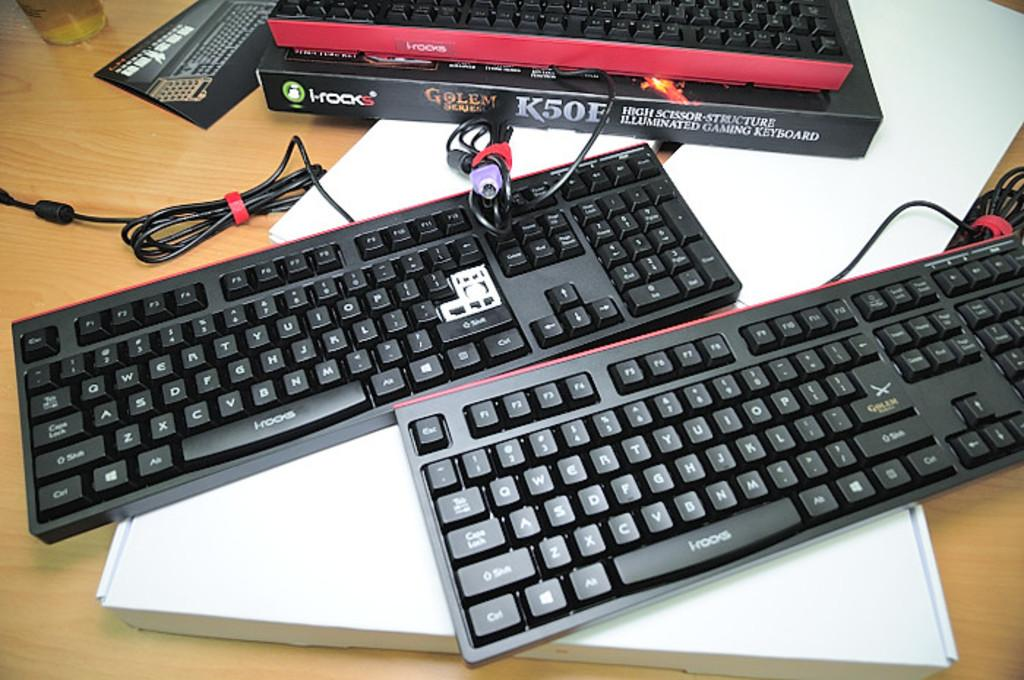<image>
Give a short and clear explanation of the subsequent image. Two keyboards sit next to an i-rocks cardboard box. 